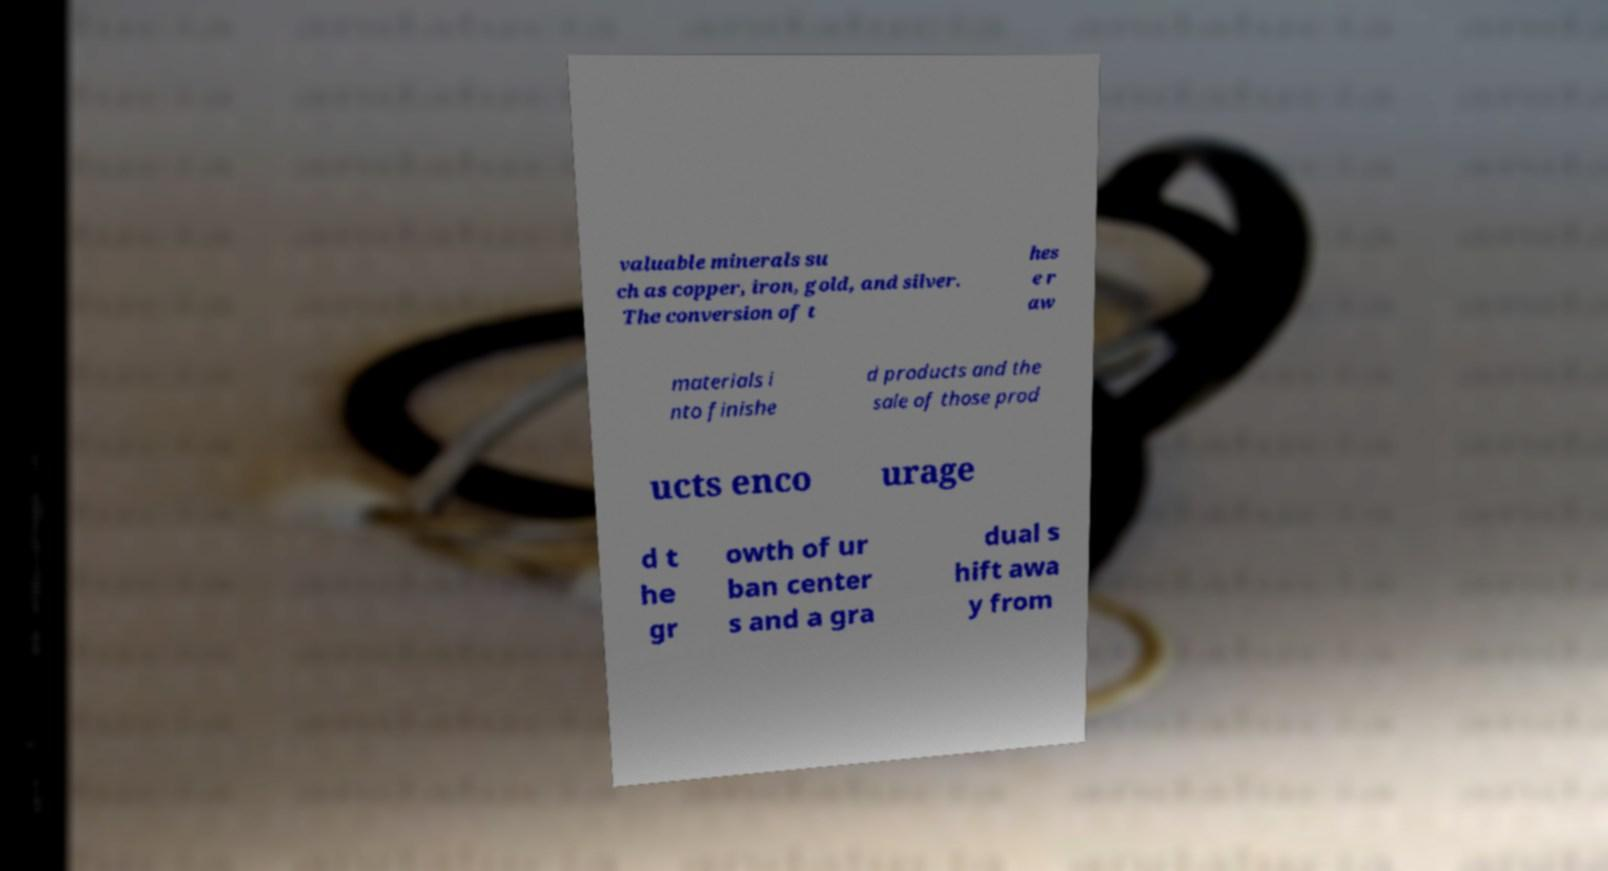Can you read and provide the text displayed in the image?This photo seems to have some interesting text. Can you extract and type it out for me? valuable minerals su ch as copper, iron, gold, and silver. The conversion of t hes e r aw materials i nto finishe d products and the sale of those prod ucts enco urage d t he gr owth of ur ban center s and a gra dual s hift awa y from 